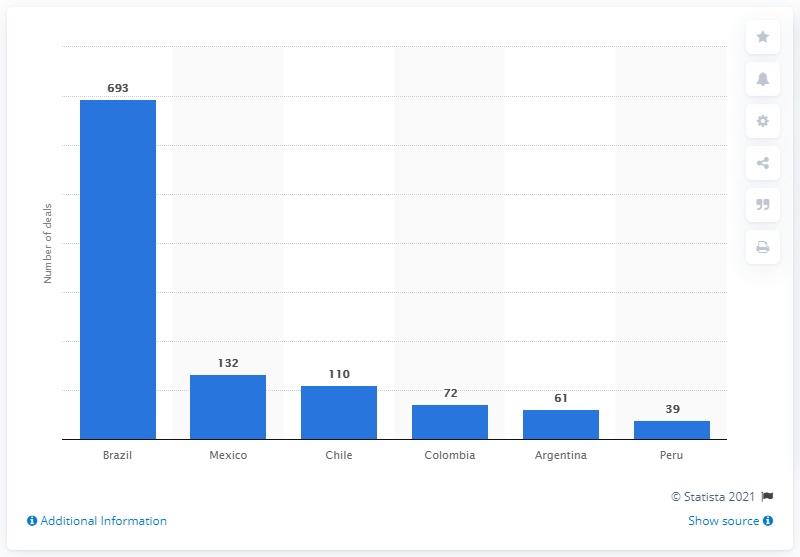Give some essential details in this illustration. There were 132 merger and acquisition deals reported in Mexico between January and May 2021. In the first five months of 2021, a total of 693 merger and acquisition deals were reported in Brazil. As of May 2021, a total of 39 merger and acquisition deals were announced in Peru. 